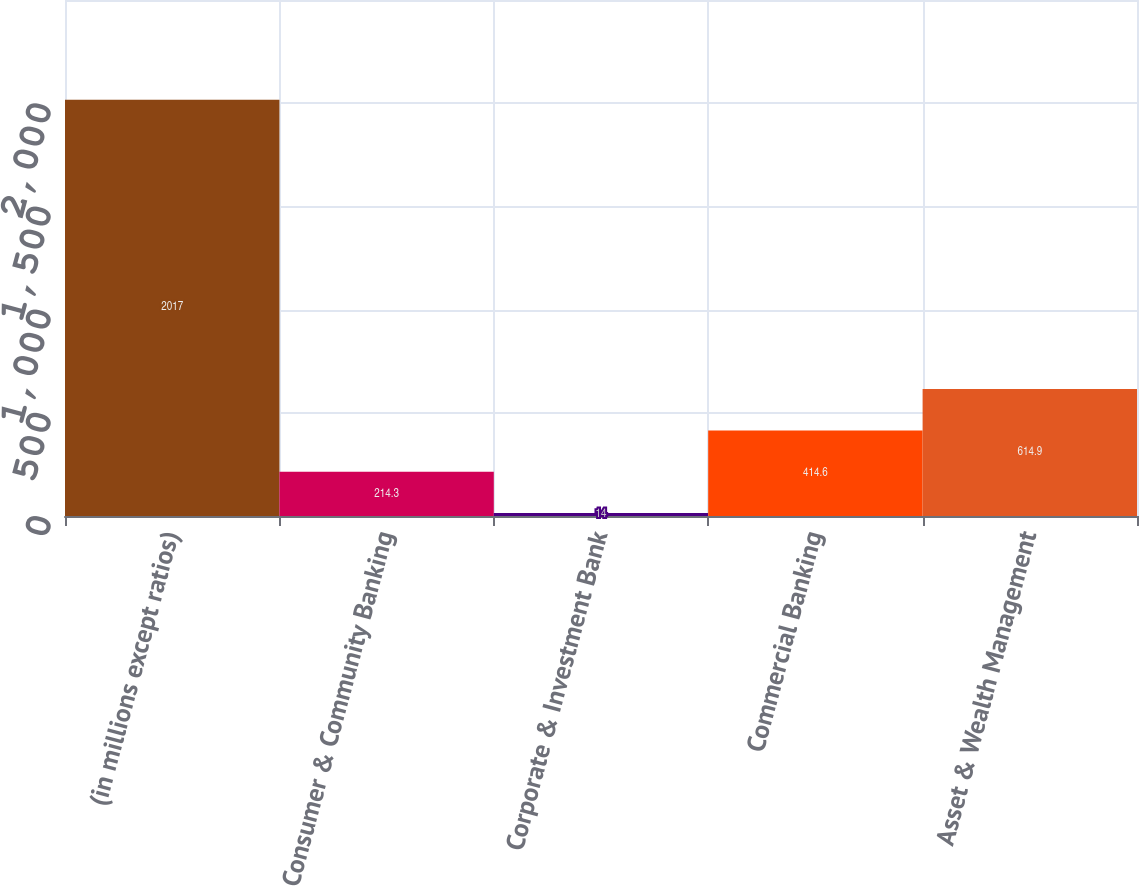<chart> <loc_0><loc_0><loc_500><loc_500><bar_chart><fcel>(in millions except ratios)<fcel>Consumer & Community Banking<fcel>Corporate & Investment Bank<fcel>Commercial Banking<fcel>Asset & Wealth Management<nl><fcel>2017<fcel>214.3<fcel>14<fcel>414.6<fcel>614.9<nl></chart> 